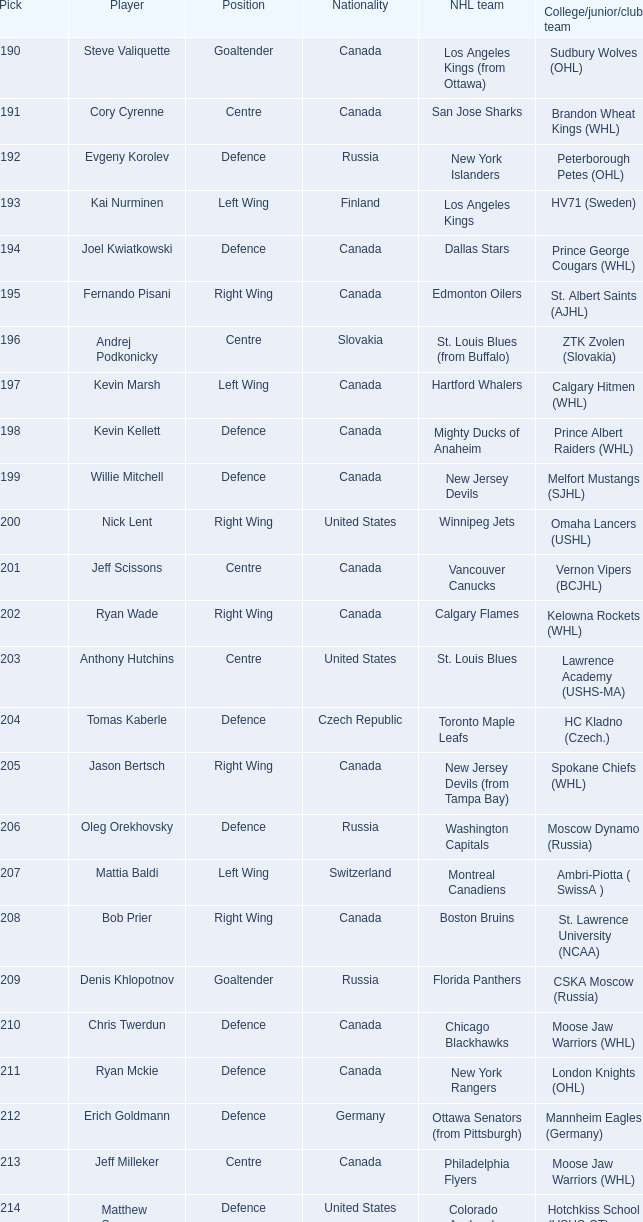Name the pick for matthew scorsune 214.0. 